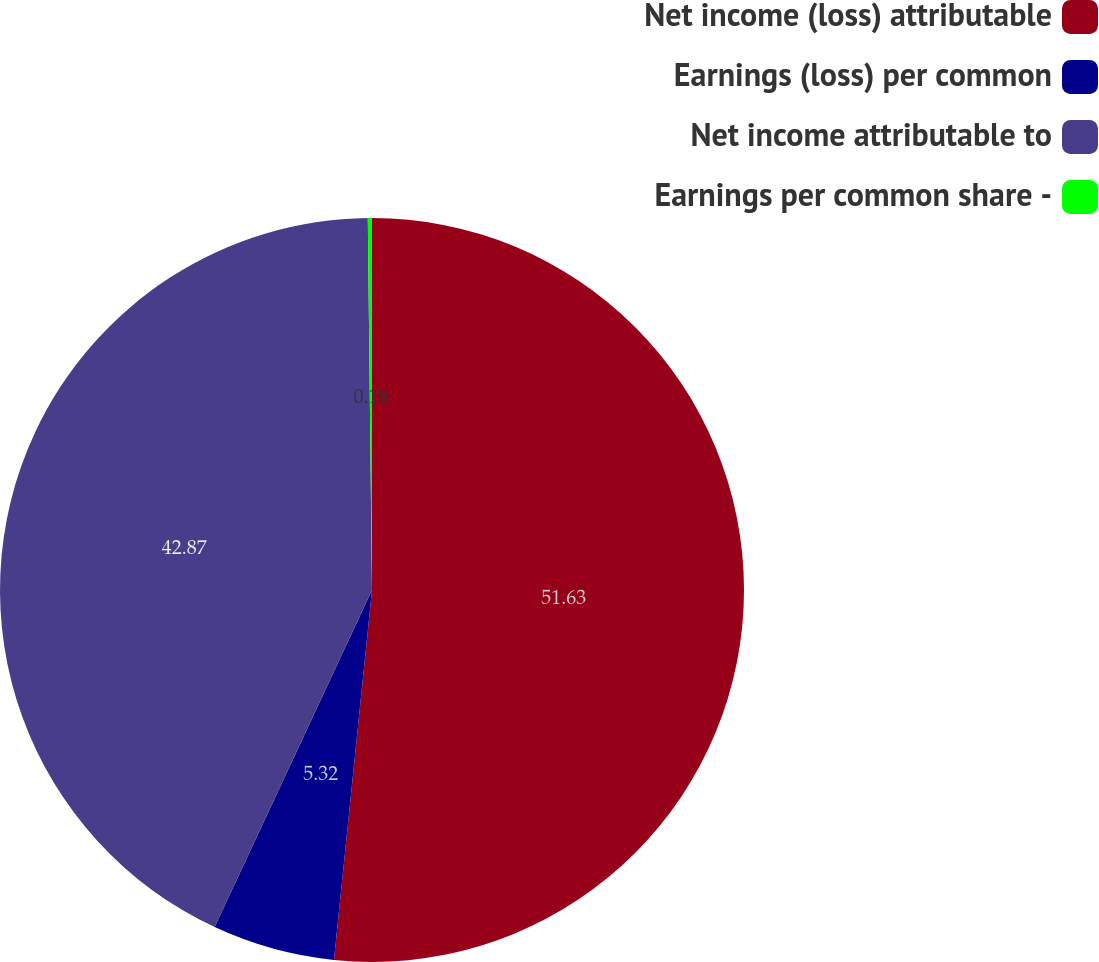<chart> <loc_0><loc_0><loc_500><loc_500><pie_chart><fcel>Net income (loss) attributable<fcel>Earnings (loss) per common<fcel>Net income attributable to<fcel>Earnings per common share -<nl><fcel>51.63%<fcel>5.32%<fcel>42.87%<fcel>0.18%<nl></chart> 